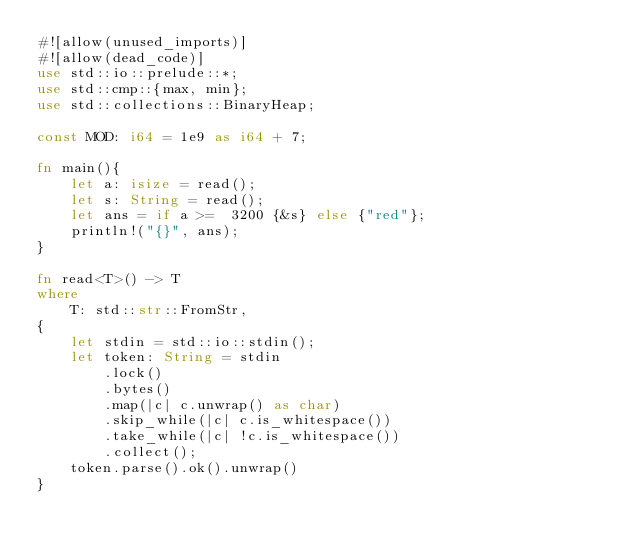Convert code to text. <code><loc_0><loc_0><loc_500><loc_500><_Rust_>#![allow(unused_imports)]
#![allow(dead_code)]
use std::io::prelude::*;
use std::cmp::{max, min};
use std::collections::BinaryHeap;

const MOD: i64 = 1e9 as i64 + 7; 

fn main(){
    let a: isize = read();
    let s: String = read();
    let ans = if a >=  3200 {&s} else {"red"};
    println!("{}", ans);
}

fn read<T>() -> T
where
    T: std::str::FromStr,
{
    let stdin = std::io::stdin();
    let token: String = stdin
        .lock()
        .bytes()
        .map(|c| c.unwrap() as char)
        .skip_while(|c| c.is_whitespace())
        .take_while(|c| !c.is_whitespace())
        .collect();
    token.parse().ok().unwrap()
}
</code> 